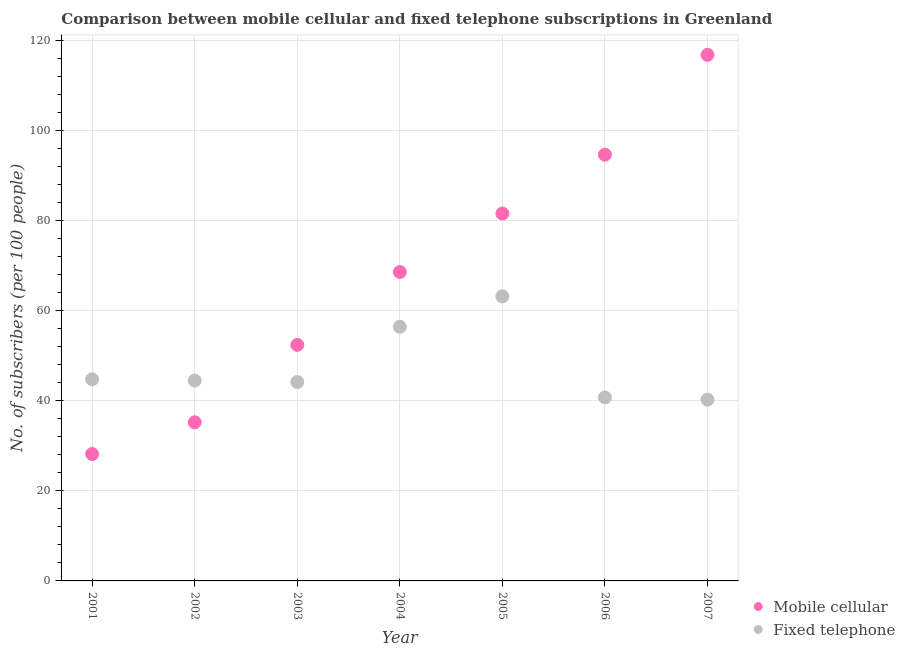How many different coloured dotlines are there?
Offer a terse response. 2. Is the number of dotlines equal to the number of legend labels?
Ensure brevity in your answer.  Yes. What is the number of mobile cellular subscribers in 2001?
Your answer should be compact. 28.19. Across all years, what is the maximum number of fixed telephone subscribers?
Your answer should be very brief. 63.21. Across all years, what is the minimum number of fixed telephone subscribers?
Give a very brief answer. 40.26. In which year was the number of fixed telephone subscribers maximum?
Your response must be concise. 2005. What is the total number of fixed telephone subscribers in the graph?
Your answer should be compact. 334.17. What is the difference between the number of mobile cellular subscribers in 2002 and that in 2006?
Offer a very short reply. -59.44. What is the difference between the number of fixed telephone subscribers in 2007 and the number of mobile cellular subscribers in 2004?
Provide a short and direct response. -28.36. What is the average number of mobile cellular subscribers per year?
Your answer should be very brief. 68.24. In the year 2001, what is the difference between the number of mobile cellular subscribers and number of fixed telephone subscribers?
Provide a short and direct response. -16.61. What is the ratio of the number of fixed telephone subscribers in 2001 to that in 2003?
Make the answer very short. 1.01. Is the difference between the number of mobile cellular subscribers in 2001 and 2005 greater than the difference between the number of fixed telephone subscribers in 2001 and 2005?
Ensure brevity in your answer.  No. What is the difference between the highest and the second highest number of mobile cellular subscribers?
Your answer should be very brief. 22.18. What is the difference between the highest and the lowest number of fixed telephone subscribers?
Offer a terse response. 22.95. How many years are there in the graph?
Give a very brief answer. 7. What is the difference between two consecutive major ticks on the Y-axis?
Offer a terse response. 20. Does the graph contain any zero values?
Offer a terse response. No. Where does the legend appear in the graph?
Your response must be concise. Bottom right. How many legend labels are there?
Your answer should be compact. 2. How are the legend labels stacked?
Ensure brevity in your answer.  Vertical. What is the title of the graph?
Keep it short and to the point. Comparison between mobile cellular and fixed telephone subscriptions in Greenland. What is the label or title of the Y-axis?
Ensure brevity in your answer.  No. of subscribers (per 100 people). What is the No. of subscribers (per 100 people) of Mobile cellular in 2001?
Offer a very short reply. 28.19. What is the No. of subscribers (per 100 people) of Fixed telephone in 2001?
Offer a very short reply. 44.8. What is the No. of subscribers (per 100 people) of Mobile cellular in 2002?
Give a very brief answer. 35.24. What is the No. of subscribers (per 100 people) in Fixed telephone in 2002?
Your answer should be compact. 44.5. What is the No. of subscribers (per 100 people) of Mobile cellular in 2003?
Provide a succinct answer. 52.44. What is the No. of subscribers (per 100 people) in Fixed telephone in 2003?
Offer a terse response. 44.18. What is the No. of subscribers (per 100 people) of Mobile cellular in 2004?
Make the answer very short. 68.62. What is the No. of subscribers (per 100 people) of Fixed telephone in 2004?
Offer a very short reply. 56.45. What is the No. of subscribers (per 100 people) of Mobile cellular in 2005?
Your answer should be compact. 81.61. What is the No. of subscribers (per 100 people) of Fixed telephone in 2005?
Keep it short and to the point. 63.21. What is the No. of subscribers (per 100 people) of Mobile cellular in 2006?
Provide a short and direct response. 94.69. What is the No. of subscribers (per 100 people) in Fixed telephone in 2006?
Offer a terse response. 40.76. What is the No. of subscribers (per 100 people) of Mobile cellular in 2007?
Your answer should be very brief. 116.87. What is the No. of subscribers (per 100 people) of Fixed telephone in 2007?
Provide a succinct answer. 40.26. Across all years, what is the maximum No. of subscribers (per 100 people) in Mobile cellular?
Provide a short and direct response. 116.87. Across all years, what is the maximum No. of subscribers (per 100 people) in Fixed telephone?
Offer a terse response. 63.21. Across all years, what is the minimum No. of subscribers (per 100 people) of Mobile cellular?
Give a very brief answer. 28.19. Across all years, what is the minimum No. of subscribers (per 100 people) in Fixed telephone?
Your answer should be very brief. 40.26. What is the total No. of subscribers (per 100 people) of Mobile cellular in the graph?
Give a very brief answer. 477.66. What is the total No. of subscribers (per 100 people) in Fixed telephone in the graph?
Offer a terse response. 334.17. What is the difference between the No. of subscribers (per 100 people) of Mobile cellular in 2001 and that in 2002?
Make the answer very short. -7.05. What is the difference between the No. of subscribers (per 100 people) of Fixed telephone in 2001 and that in 2002?
Keep it short and to the point. 0.3. What is the difference between the No. of subscribers (per 100 people) in Mobile cellular in 2001 and that in 2003?
Ensure brevity in your answer.  -24.25. What is the difference between the No. of subscribers (per 100 people) in Fixed telephone in 2001 and that in 2003?
Your answer should be very brief. 0.63. What is the difference between the No. of subscribers (per 100 people) in Mobile cellular in 2001 and that in 2004?
Make the answer very short. -40.43. What is the difference between the No. of subscribers (per 100 people) of Fixed telephone in 2001 and that in 2004?
Provide a short and direct response. -11.65. What is the difference between the No. of subscribers (per 100 people) in Mobile cellular in 2001 and that in 2005?
Your response must be concise. -53.42. What is the difference between the No. of subscribers (per 100 people) of Fixed telephone in 2001 and that in 2005?
Provide a short and direct response. -18.41. What is the difference between the No. of subscribers (per 100 people) in Mobile cellular in 2001 and that in 2006?
Your answer should be very brief. -66.49. What is the difference between the No. of subscribers (per 100 people) in Fixed telephone in 2001 and that in 2006?
Offer a terse response. 4.04. What is the difference between the No. of subscribers (per 100 people) of Mobile cellular in 2001 and that in 2007?
Your response must be concise. -88.68. What is the difference between the No. of subscribers (per 100 people) of Fixed telephone in 2001 and that in 2007?
Offer a terse response. 4.54. What is the difference between the No. of subscribers (per 100 people) in Mobile cellular in 2002 and that in 2003?
Your response must be concise. -17.2. What is the difference between the No. of subscribers (per 100 people) of Fixed telephone in 2002 and that in 2003?
Provide a succinct answer. 0.33. What is the difference between the No. of subscribers (per 100 people) in Mobile cellular in 2002 and that in 2004?
Keep it short and to the point. -33.38. What is the difference between the No. of subscribers (per 100 people) of Fixed telephone in 2002 and that in 2004?
Your answer should be compact. -11.95. What is the difference between the No. of subscribers (per 100 people) in Mobile cellular in 2002 and that in 2005?
Offer a terse response. -46.37. What is the difference between the No. of subscribers (per 100 people) in Fixed telephone in 2002 and that in 2005?
Provide a succinct answer. -18.71. What is the difference between the No. of subscribers (per 100 people) in Mobile cellular in 2002 and that in 2006?
Provide a short and direct response. -59.44. What is the difference between the No. of subscribers (per 100 people) in Fixed telephone in 2002 and that in 2006?
Provide a short and direct response. 3.74. What is the difference between the No. of subscribers (per 100 people) in Mobile cellular in 2002 and that in 2007?
Your answer should be very brief. -81.62. What is the difference between the No. of subscribers (per 100 people) in Fixed telephone in 2002 and that in 2007?
Provide a succinct answer. 4.24. What is the difference between the No. of subscribers (per 100 people) in Mobile cellular in 2003 and that in 2004?
Keep it short and to the point. -16.18. What is the difference between the No. of subscribers (per 100 people) of Fixed telephone in 2003 and that in 2004?
Offer a very short reply. -12.28. What is the difference between the No. of subscribers (per 100 people) of Mobile cellular in 2003 and that in 2005?
Make the answer very short. -29.17. What is the difference between the No. of subscribers (per 100 people) of Fixed telephone in 2003 and that in 2005?
Give a very brief answer. -19.03. What is the difference between the No. of subscribers (per 100 people) in Mobile cellular in 2003 and that in 2006?
Your response must be concise. -42.25. What is the difference between the No. of subscribers (per 100 people) of Fixed telephone in 2003 and that in 2006?
Ensure brevity in your answer.  3.42. What is the difference between the No. of subscribers (per 100 people) in Mobile cellular in 2003 and that in 2007?
Offer a very short reply. -64.43. What is the difference between the No. of subscribers (per 100 people) in Fixed telephone in 2003 and that in 2007?
Your answer should be very brief. 3.92. What is the difference between the No. of subscribers (per 100 people) in Mobile cellular in 2004 and that in 2005?
Ensure brevity in your answer.  -12.99. What is the difference between the No. of subscribers (per 100 people) in Fixed telephone in 2004 and that in 2005?
Provide a succinct answer. -6.76. What is the difference between the No. of subscribers (per 100 people) in Mobile cellular in 2004 and that in 2006?
Keep it short and to the point. -26.06. What is the difference between the No. of subscribers (per 100 people) of Fixed telephone in 2004 and that in 2006?
Ensure brevity in your answer.  15.69. What is the difference between the No. of subscribers (per 100 people) in Mobile cellular in 2004 and that in 2007?
Your answer should be very brief. -48.24. What is the difference between the No. of subscribers (per 100 people) in Fixed telephone in 2004 and that in 2007?
Your answer should be compact. 16.19. What is the difference between the No. of subscribers (per 100 people) in Mobile cellular in 2005 and that in 2006?
Make the answer very short. -13.07. What is the difference between the No. of subscribers (per 100 people) of Fixed telephone in 2005 and that in 2006?
Give a very brief answer. 22.45. What is the difference between the No. of subscribers (per 100 people) of Mobile cellular in 2005 and that in 2007?
Your response must be concise. -35.26. What is the difference between the No. of subscribers (per 100 people) in Fixed telephone in 2005 and that in 2007?
Your response must be concise. 22.95. What is the difference between the No. of subscribers (per 100 people) of Mobile cellular in 2006 and that in 2007?
Give a very brief answer. -22.18. What is the difference between the No. of subscribers (per 100 people) in Fixed telephone in 2006 and that in 2007?
Your response must be concise. 0.5. What is the difference between the No. of subscribers (per 100 people) in Mobile cellular in 2001 and the No. of subscribers (per 100 people) in Fixed telephone in 2002?
Provide a short and direct response. -16.31. What is the difference between the No. of subscribers (per 100 people) in Mobile cellular in 2001 and the No. of subscribers (per 100 people) in Fixed telephone in 2003?
Make the answer very short. -15.99. What is the difference between the No. of subscribers (per 100 people) in Mobile cellular in 2001 and the No. of subscribers (per 100 people) in Fixed telephone in 2004?
Keep it short and to the point. -28.26. What is the difference between the No. of subscribers (per 100 people) in Mobile cellular in 2001 and the No. of subscribers (per 100 people) in Fixed telephone in 2005?
Provide a succinct answer. -35.02. What is the difference between the No. of subscribers (per 100 people) in Mobile cellular in 2001 and the No. of subscribers (per 100 people) in Fixed telephone in 2006?
Offer a terse response. -12.57. What is the difference between the No. of subscribers (per 100 people) in Mobile cellular in 2001 and the No. of subscribers (per 100 people) in Fixed telephone in 2007?
Provide a short and direct response. -12.07. What is the difference between the No. of subscribers (per 100 people) in Mobile cellular in 2002 and the No. of subscribers (per 100 people) in Fixed telephone in 2003?
Ensure brevity in your answer.  -8.93. What is the difference between the No. of subscribers (per 100 people) in Mobile cellular in 2002 and the No. of subscribers (per 100 people) in Fixed telephone in 2004?
Offer a very short reply. -21.21. What is the difference between the No. of subscribers (per 100 people) in Mobile cellular in 2002 and the No. of subscribers (per 100 people) in Fixed telephone in 2005?
Provide a short and direct response. -27.97. What is the difference between the No. of subscribers (per 100 people) in Mobile cellular in 2002 and the No. of subscribers (per 100 people) in Fixed telephone in 2006?
Your answer should be very brief. -5.52. What is the difference between the No. of subscribers (per 100 people) in Mobile cellular in 2002 and the No. of subscribers (per 100 people) in Fixed telephone in 2007?
Offer a very short reply. -5.02. What is the difference between the No. of subscribers (per 100 people) of Mobile cellular in 2003 and the No. of subscribers (per 100 people) of Fixed telephone in 2004?
Offer a terse response. -4.01. What is the difference between the No. of subscribers (per 100 people) in Mobile cellular in 2003 and the No. of subscribers (per 100 people) in Fixed telephone in 2005?
Provide a succinct answer. -10.77. What is the difference between the No. of subscribers (per 100 people) in Mobile cellular in 2003 and the No. of subscribers (per 100 people) in Fixed telephone in 2006?
Ensure brevity in your answer.  11.68. What is the difference between the No. of subscribers (per 100 people) of Mobile cellular in 2003 and the No. of subscribers (per 100 people) of Fixed telephone in 2007?
Offer a terse response. 12.18. What is the difference between the No. of subscribers (per 100 people) of Mobile cellular in 2004 and the No. of subscribers (per 100 people) of Fixed telephone in 2005?
Give a very brief answer. 5.41. What is the difference between the No. of subscribers (per 100 people) in Mobile cellular in 2004 and the No. of subscribers (per 100 people) in Fixed telephone in 2006?
Provide a short and direct response. 27.86. What is the difference between the No. of subscribers (per 100 people) in Mobile cellular in 2004 and the No. of subscribers (per 100 people) in Fixed telephone in 2007?
Your answer should be very brief. 28.36. What is the difference between the No. of subscribers (per 100 people) in Mobile cellular in 2005 and the No. of subscribers (per 100 people) in Fixed telephone in 2006?
Provide a succinct answer. 40.85. What is the difference between the No. of subscribers (per 100 people) in Mobile cellular in 2005 and the No. of subscribers (per 100 people) in Fixed telephone in 2007?
Provide a succinct answer. 41.35. What is the difference between the No. of subscribers (per 100 people) of Mobile cellular in 2006 and the No. of subscribers (per 100 people) of Fixed telephone in 2007?
Offer a terse response. 54.42. What is the average No. of subscribers (per 100 people) of Mobile cellular per year?
Your answer should be very brief. 68.24. What is the average No. of subscribers (per 100 people) in Fixed telephone per year?
Keep it short and to the point. 47.74. In the year 2001, what is the difference between the No. of subscribers (per 100 people) of Mobile cellular and No. of subscribers (per 100 people) of Fixed telephone?
Provide a short and direct response. -16.61. In the year 2002, what is the difference between the No. of subscribers (per 100 people) in Mobile cellular and No. of subscribers (per 100 people) in Fixed telephone?
Your response must be concise. -9.26. In the year 2003, what is the difference between the No. of subscribers (per 100 people) of Mobile cellular and No. of subscribers (per 100 people) of Fixed telephone?
Make the answer very short. 8.26. In the year 2004, what is the difference between the No. of subscribers (per 100 people) in Mobile cellular and No. of subscribers (per 100 people) in Fixed telephone?
Make the answer very short. 12.17. In the year 2005, what is the difference between the No. of subscribers (per 100 people) of Mobile cellular and No. of subscribers (per 100 people) of Fixed telephone?
Offer a terse response. 18.4. In the year 2006, what is the difference between the No. of subscribers (per 100 people) in Mobile cellular and No. of subscribers (per 100 people) in Fixed telephone?
Ensure brevity in your answer.  53.93. In the year 2007, what is the difference between the No. of subscribers (per 100 people) of Mobile cellular and No. of subscribers (per 100 people) of Fixed telephone?
Your answer should be compact. 76.61. What is the ratio of the No. of subscribers (per 100 people) in Mobile cellular in 2001 to that in 2002?
Your answer should be very brief. 0.8. What is the ratio of the No. of subscribers (per 100 people) of Fixed telephone in 2001 to that in 2002?
Provide a succinct answer. 1.01. What is the ratio of the No. of subscribers (per 100 people) of Mobile cellular in 2001 to that in 2003?
Keep it short and to the point. 0.54. What is the ratio of the No. of subscribers (per 100 people) of Fixed telephone in 2001 to that in 2003?
Ensure brevity in your answer.  1.01. What is the ratio of the No. of subscribers (per 100 people) of Mobile cellular in 2001 to that in 2004?
Give a very brief answer. 0.41. What is the ratio of the No. of subscribers (per 100 people) in Fixed telephone in 2001 to that in 2004?
Offer a terse response. 0.79. What is the ratio of the No. of subscribers (per 100 people) of Mobile cellular in 2001 to that in 2005?
Ensure brevity in your answer.  0.35. What is the ratio of the No. of subscribers (per 100 people) in Fixed telephone in 2001 to that in 2005?
Your answer should be very brief. 0.71. What is the ratio of the No. of subscribers (per 100 people) in Mobile cellular in 2001 to that in 2006?
Offer a terse response. 0.3. What is the ratio of the No. of subscribers (per 100 people) of Fixed telephone in 2001 to that in 2006?
Offer a terse response. 1.1. What is the ratio of the No. of subscribers (per 100 people) of Mobile cellular in 2001 to that in 2007?
Offer a terse response. 0.24. What is the ratio of the No. of subscribers (per 100 people) of Fixed telephone in 2001 to that in 2007?
Offer a very short reply. 1.11. What is the ratio of the No. of subscribers (per 100 people) of Mobile cellular in 2002 to that in 2003?
Make the answer very short. 0.67. What is the ratio of the No. of subscribers (per 100 people) in Fixed telephone in 2002 to that in 2003?
Provide a short and direct response. 1.01. What is the ratio of the No. of subscribers (per 100 people) in Mobile cellular in 2002 to that in 2004?
Make the answer very short. 0.51. What is the ratio of the No. of subscribers (per 100 people) of Fixed telephone in 2002 to that in 2004?
Keep it short and to the point. 0.79. What is the ratio of the No. of subscribers (per 100 people) in Mobile cellular in 2002 to that in 2005?
Ensure brevity in your answer.  0.43. What is the ratio of the No. of subscribers (per 100 people) in Fixed telephone in 2002 to that in 2005?
Ensure brevity in your answer.  0.7. What is the ratio of the No. of subscribers (per 100 people) in Mobile cellular in 2002 to that in 2006?
Your answer should be compact. 0.37. What is the ratio of the No. of subscribers (per 100 people) of Fixed telephone in 2002 to that in 2006?
Offer a terse response. 1.09. What is the ratio of the No. of subscribers (per 100 people) of Mobile cellular in 2002 to that in 2007?
Your response must be concise. 0.3. What is the ratio of the No. of subscribers (per 100 people) in Fixed telephone in 2002 to that in 2007?
Ensure brevity in your answer.  1.11. What is the ratio of the No. of subscribers (per 100 people) of Mobile cellular in 2003 to that in 2004?
Offer a terse response. 0.76. What is the ratio of the No. of subscribers (per 100 people) in Fixed telephone in 2003 to that in 2004?
Provide a succinct answer. 0.78. What is the ratio of the No. of subscribers (per 100 people) in Mobile cellular in 2003 to that in 2005?
Offer a terse response. 0.64. What is the ratio of the No. of subscribers (per 100 people) in Fixed telephone in 2003 to that in 2005?
Give a very brief answer. 0.7. What is the ratio of the No. of subscribers (per 100 people) of Mobile cellular in 2003 to that in 2006?
Provide a succinct answer. 0.55. What is the ratio of the No. of subscribers (per 100 people) of Fixed telephone in 2003 to that in 2006?
Ensure brevity in your answer.  1.08. What is the ratio of the No. of subscribers (per 100 people) in Mobile cellular in 2003 to that in 2007?
Offer a very short reply. 0.45. What is the ratio of the No. of subscribers (per 100 people) of Fixed telephone in 2003 to that in 2007?
Your answer should be very brief. 1.1. What is the ratio of the No. of subscribers (per 100 people) of Mobile cellular in 2004 to that in 2005?
Ensure brevity in your answer.  0.84. What is the ratio of the No. of subscribers (per 100 people) in Fixed telephone in 2004 to that in 2005?
Make the answer very short. 0.89. What is the ratio of the No. of subscribers (per 100 people) in Mobile cellular in 2004 to that in 2006?
Ensure brevity in your answer.  0.72. What is the ratio of the No. of subscribers (per 100 people) in Fixed telephone in 2004 to that in 2006?
Your answer should be very brief. 1.39. What is the ratio of the No. of subscribers (per 100 people) in Mobile cellular in 2004 to that in 2007?
Provide a short and direct response. 0.59. What is the ratio of the No. of subscribers (per 100 people) of Fixed telephone in 2004 to that in 2007?
Your answer should be very brief. 1.4. What is the ratio of the No. of subscribers (per 100 people) in Mobile cellular in 2005 to that in 2006?
Make the answer very short. 0.86. What is the ratio of the No. of subscribers (per 100 people) in Fixed telephone in 2005 to that in 2006?
Your answer should be compact. 1.55. What is the ratio of the No. of subscribers (per 100 people) of Mobile cellular in 2005 to that in 2007?
Your answer should be compact. 0.7. What is the ratio of the No. of subscribers (per 100 people) in Fixed telephone in 2005 to that in 2007?
Keep it short and to the point. 1.57. What is the ratio of the No. of subscribers (per 100 people) of Mobile cellular in 2006 to that in 2007?
Offer a very short reply. 0.81. What is the ratio of the No. of subscribers (per 100 people) of Fixed telephone in 2006 to that in 2007?
Provide a succinct answer. 1.01. What is the difference between the highest and the second highest No. of subscribers (per 100 people) of Mobile cellular?
Your answer should be compact. 22.18. What is the difference between the highest and the second highest No. of subscribers (per 100 people) in Fixed telephone?
Make the answer very short. 6.76. What is the difference between the highest and the lowest No. of subscribers (per 100 people) of Mobile cellular?
Ensure brevity in your answer.  88.68. What is the difference between the highest and the lowest No. of subscribers (per 100 people) in Fixed telephone?
Keep it short and to the point. 22.95. 